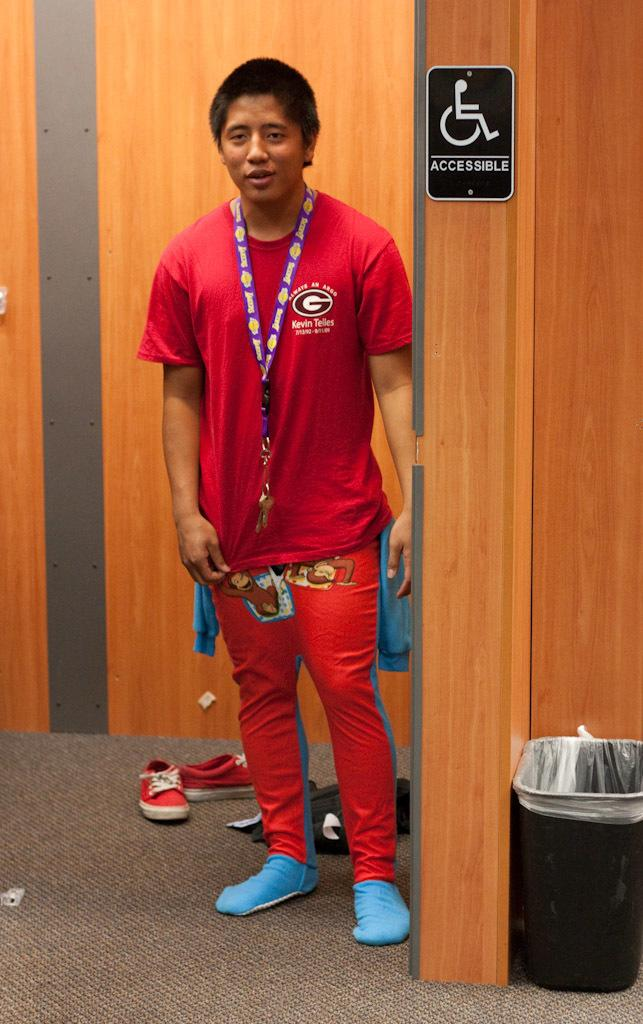<image>
Write a terse but informative summary of the picture. The athlete Kevin Telles comes out of the disabled accessible toilets. 